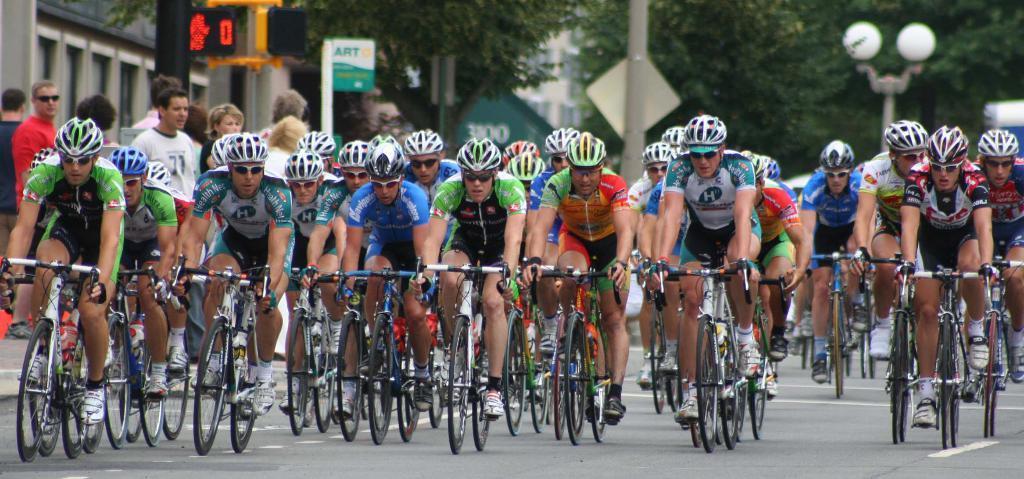How would you summarize this image in a sentence or two? In this image there are few persons riding bicycles on the road. They are wearing goggles and helmets. Left side there are few persons standing on the pavement. Right side there is a street light. Middle of the image there is a board attached to the pole. Left side there is a pole having a traffic light attached to it. Beside there is a pole having a board. Background there are few buildings and trees. 